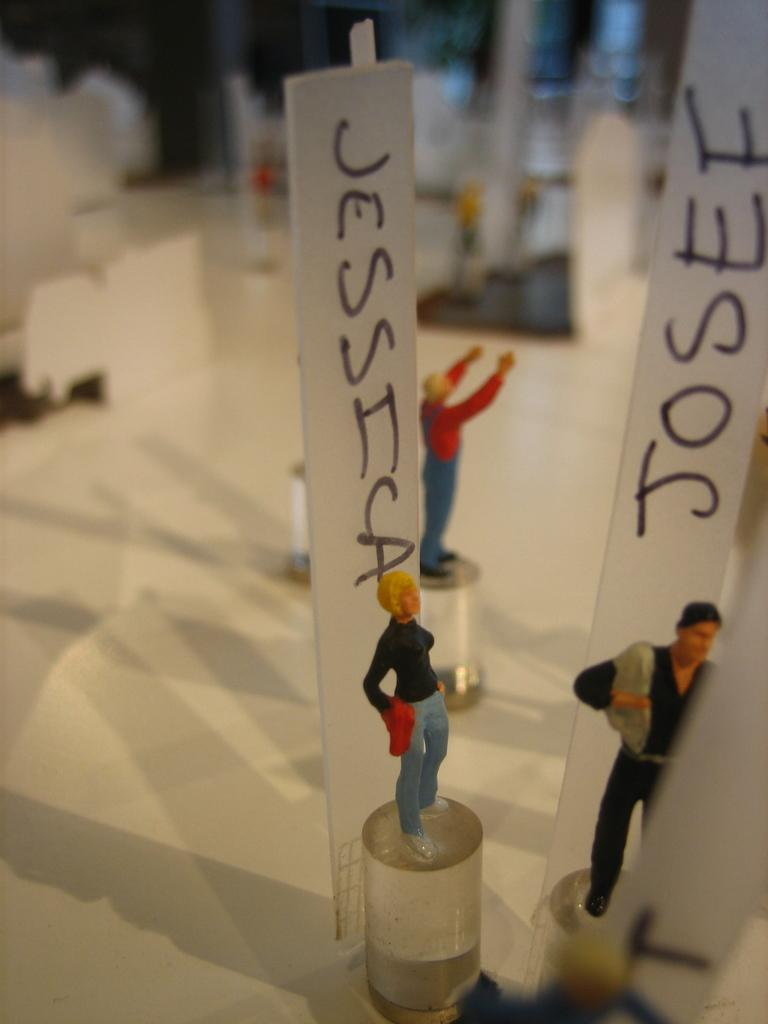What is located in the center of the image? There are toys in the center of the image. What can be seen in the front of the image? There are papers with text written on them in the front of the image. Can you describe the background of the image? The background of the image is blurry. What type of copper material is present in the image? There is no copper material present in the image. On what surface are the toys placed in the image? The provided facts do not mention a table or any surface, so we cannot determine where the toys are placed. 